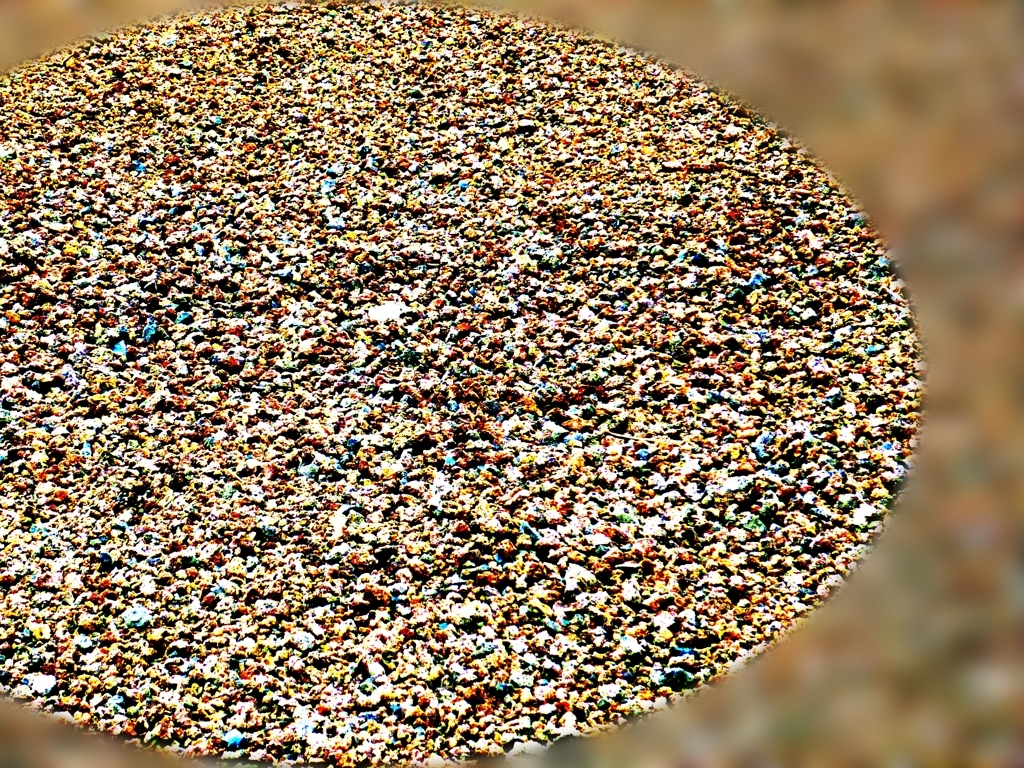Is there noticeable noise present in the image? Upon examining the image, it is apparent that there are visual distortions that could be perceived as noise, particularly affecting the clarity of the image's details. These distortions manifest as graininess, but to determine if this effect is intentional or the result of photographic noise, one would need additional information about the image's context and purpose. 